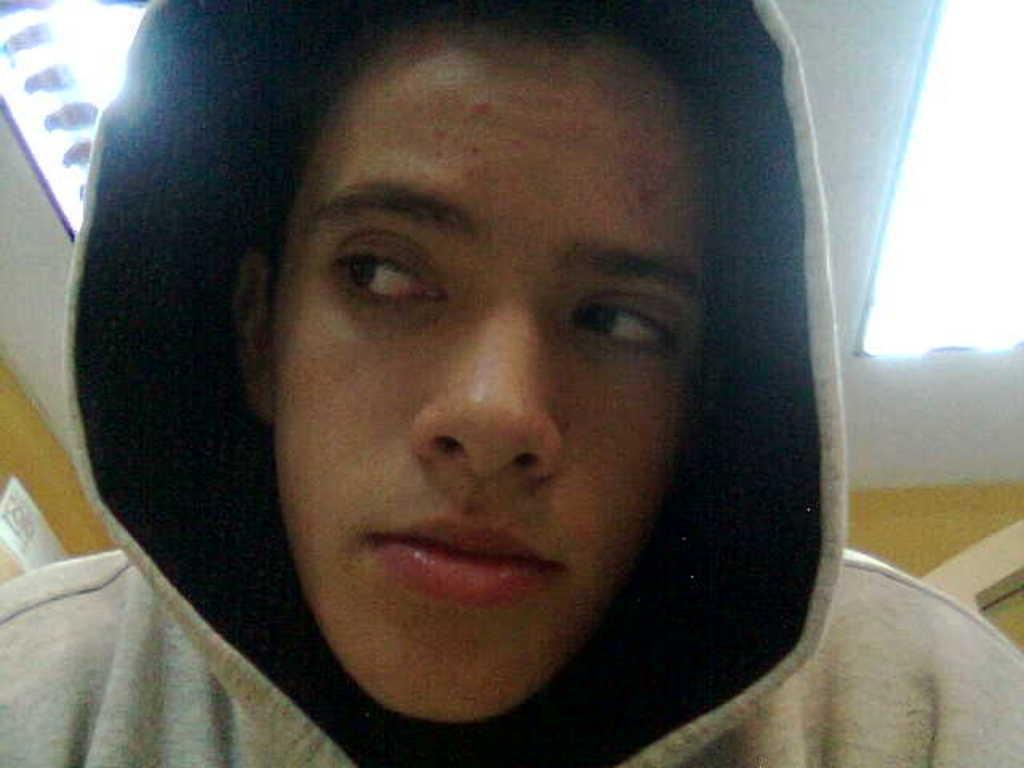Who or what is present in the image? There is a person in the image. What is the person wearing on their head? The person is wearing a cap. What part of the room can be seen in the image? The ceiling is visible in the image. How many people are playing chess in the image? There is no chess game or crowd present in the image; it only features a person wearing a cap. 